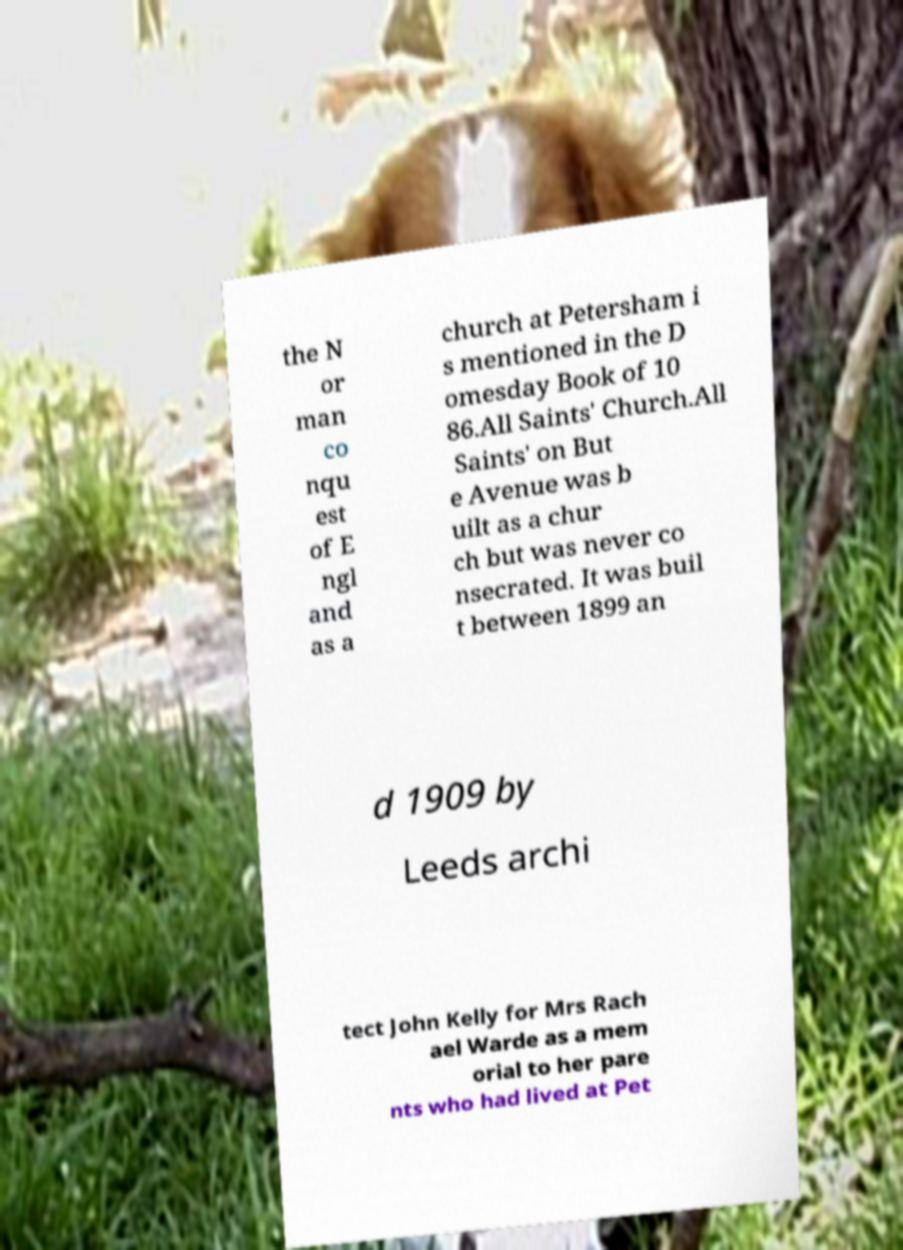What messages or text are displayed in this image? I need them in a readable, typed format. the N or man co nqu est of E ngl and as a church at Petersham i s mentioned in the D omesday Book of 10 86.All Saints' Church.All Saints' on But e Avenue was b uilt as a chur ch but was never co nsecrated. It was buil t between 1899 an d 1909 by Leeds archi tect John Kelly for Mrs Rach ael Warde as a mem orial to her pare nts who had lived at Pet 